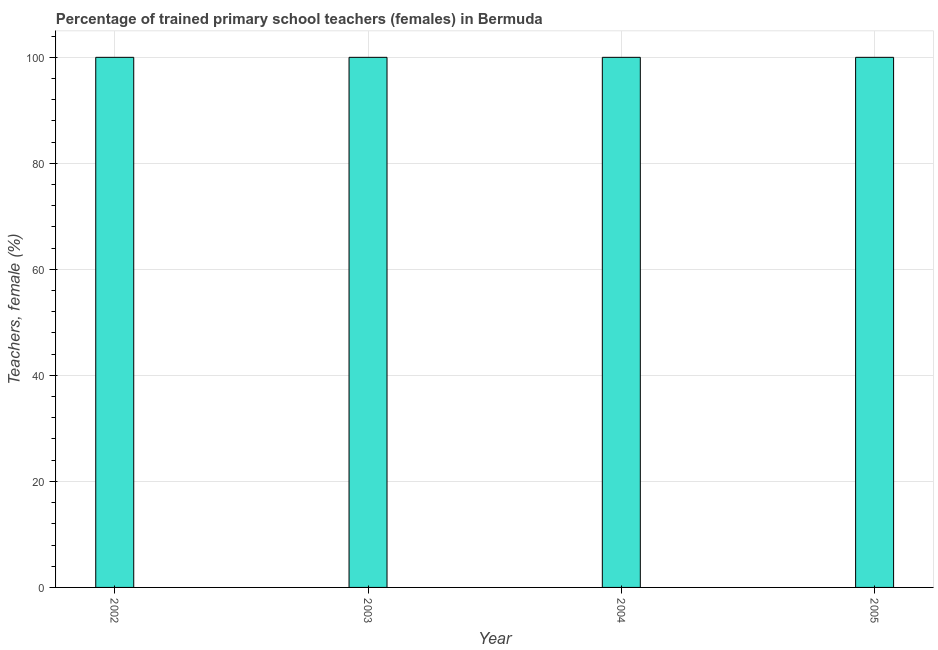Does the graph contain any zero values?
Ensure brevity in your answer.  No. What is the title of the graph?
Your answer should be very brief. Percentage of trained primary school teachers (females) in Bermuda. What is the label or title of the X-axis?
Your answer should be very brief. Year. What is the label or title of the Y-axis?
Your response must be concise. Teachers, female (%). What is the percentage of trained female teachers in 2003?
Your answer should be very brief. 100. In which year was the percentage of trained female teachers maximum?
Offer a very short reply. 2002. In which year was the percentage of trained female teachers minimum?
Your answer should be very brief. 2002. What is the sum of the percentage of trained female teachers?
Keep it short and to the point. 400. What is the difference between the percentage of trained female teachers in 2003 and 2004?
Your response must be concise. 0. What is the average percentage of trained female teachers per year?
Your response must be concise. 100. What is the median percentage of trained female teachers?
Keep it short and to the point. 100. In how many years, is the percentage of trained female teachers greater than 4 %?
Offer a terse response. 4. What is the ratio of the percentage of trained female teachers in 2003 to that in 2004?
Offer a very short reply. 1. What is the difference between the highest and the lowest percentage of trained female teachers?
Give a very brief answer. 0. How many bars are there?
Offer a very short reply. 4. What is the difference between the Teachers, female (%) in 2002 and 2003?
Make the answer very short. 0. What is the difference between the Teachers, female (%) in 2003 and 2004?
Give a very brief answer. 0. What is the ratio of the Teachers, female (%) in 2002 to that in 2003?
Offer a terse response. 1. What is the ratio of the Teachers, female (%) in 2002 to that in 2004?
Make the answer very short. 1. What is the ratio of the Teachers, female (%) in 2002 to that in 2005?
Provide a succinct answer. 1. What is the ratio of the Teachers, female (%) in 2004 to that in 2005?
Make the answer very short. 1. 